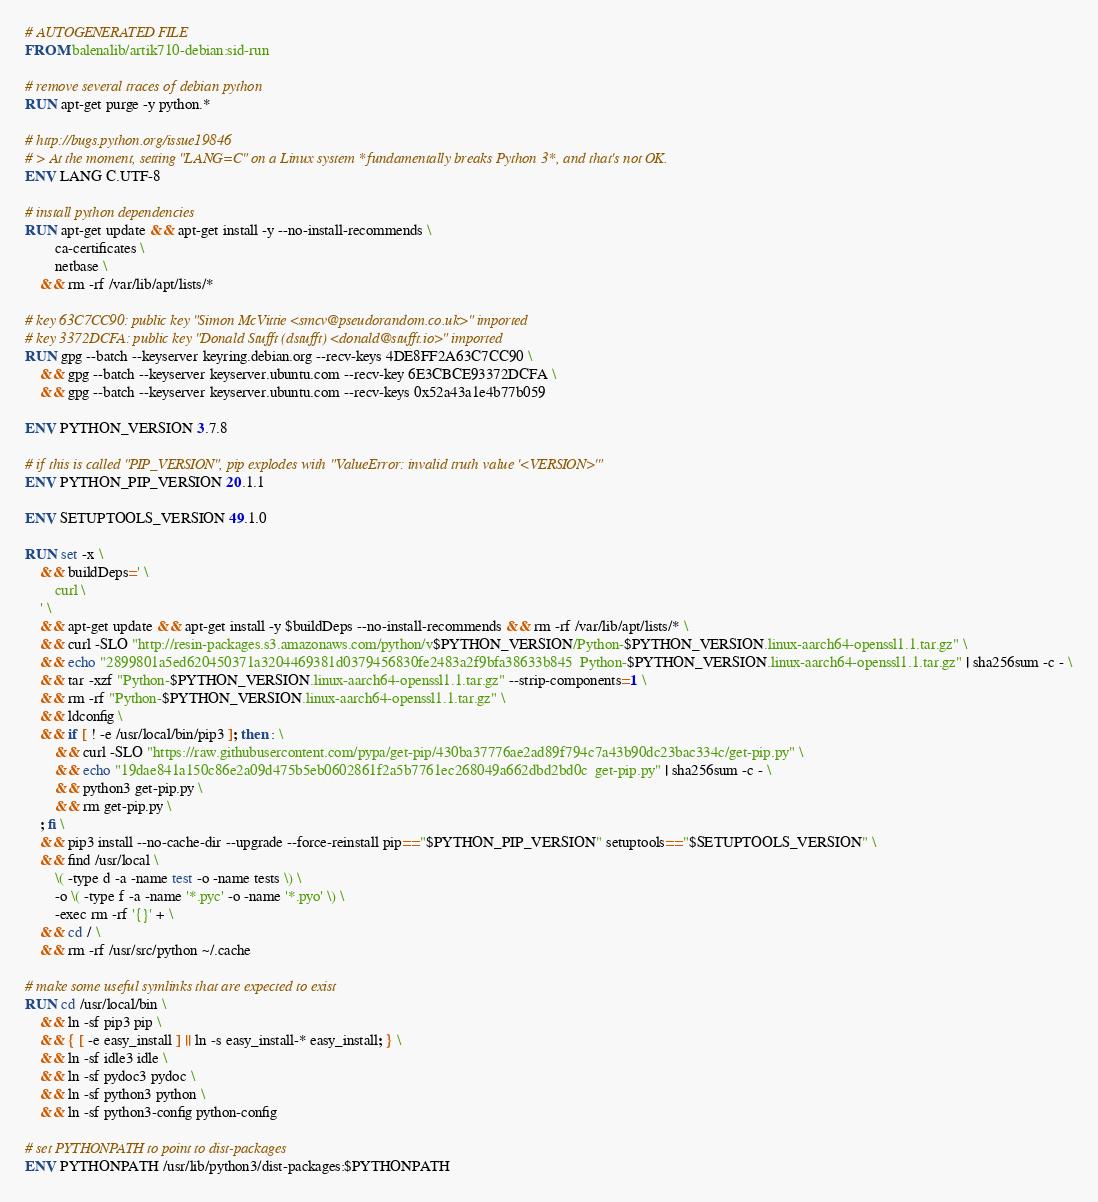Convert code to text. <code><loc_0><loc_0><loc_500><loc_500><_Dockerfile_># AUTOGENERATED FILE
FROM balenalib/artik710-debian:sid-run

# remove several traces of debian python
RUN apt-get purge -y python.*

# http://bugs.python.org/issue19846
# > At the moment, setting "LANG=C" on a Linux system *fundamentally breaks Python 3*, and that's not OK.
ENV LANG C.UTF-8

# install python dependencies
RUN apt-get update && apt-get install -y --no-install-recommends \
		ca-certificates \
		netbase \
	&& rm -rf /var/lib/apt/lists/*

# key 63C7CC90: public key "Simon McVittie <smcv@pseudorandom.co.uk>" imported
# key 3372DCFA: public key "Donald Stufft (dstufft) <donald@stufft.io>" imported
RUN gpg --batch --keyserver keyring.debian.org --recv-keys 4DE8FF2A63C7CC90 \
	&& gpg --batch --keyserver keyserver.ubuntu.com --recv-key 6E3CBCE93372DCFA \
	&& gpg --batch --keyserver keyserver.ubuntu.com --recv-keys 0x52a43a1e4b77b059

ENV PYTHON_VERSION 3.7.8

# if this is called "PIP_VERSION", pip explodes with "ValueError: invalid truth value '<VERSION>'"
ENV PYTHON_PIP_VERSION 20.1.1

ENV SETUPTOOLS_VERSION 49.1.0

RUN set -x \
	&& buildDeps=' \
		curl \
	' \
	&& apt-get update && apt-get install -y $buildDeps --no-install-recommends && rm -rf /var/lib/apt/lists/* \
	&& curl -SLO "http://resin-packages.s3.amazonaws.com/python/v$PYTHON_VERSION/Python-$PYTHON_VERSION.linux-aarch64-openssl1.1.tar.gz" \
	&& echo "2899801a5ed620450371a3204469381d0379456830fe2483a2f9bfa38633b845  Python-$PYTHON_VERSION.linux-aarch64-openssl1.1.tar.gz" | sha256sum -c - \
	&& tar -xzf "Python-$PYTHON_VERSION.linux-aarch64-openssl1.1.tar.gz" --strip-components=1 \
	&& rm -rf "Python-$PYTHON_VERSION.linux-aarch64-openssl1.1.tar.gz" \
	&& ldconfig \
	&& if [ ! -e /usr/local/bin/pip3 ]; then : \
		&& curl -SLO "https://raw.githubusercontent.com/pypa/get-pip/430ba37776ae2ad89f794c7a43b90dc23bac334c/get-pip.py" \
		&& echo "19dae841a150c86e2a09d475b5eb0602861f2a5b7761ec268049a662dbd2bd0c  get-pip.py" | sha256sum -c - \
		&& python3 get-pip.py \
		&& rm get-pip.py \
	; fi \
	&& pip3 install --no-cache-dir --upgrade --force-reinstall pip=="$PYTHON_PIP_VERSION" setuptools=="$SETUPTOOLS_VERSION" \
	&& find /usr/local \
		\( -type d -a -name test -o -name tests \) \
		-o \( -type f -a -name '*.pyc' -o -name '*.pyo' \) \
		-exec rm -rf '{}' + \
	&& cd / \
	&& rm -rf /usr/src/python ~/.cache

# make some useful symlinks that are expected to exist
RUN cd /usr/local/bin \
	&& ln -sf pip3 pip \
	&& { [ -e easy_install ] || ln -s easy_install-* easy_install; } \
	&& ln -sf idle3 idle \
	&& ln -sf pydoc3 pydoc \
	&& ln -sf python3 python \
	&& ln -sf python3-config python-config

# set PYTHONPATH to point to dist-packages
ENV PYTHONPATH /usr/lib/python3/dist-packages:$PYTHONPATH
</code> 